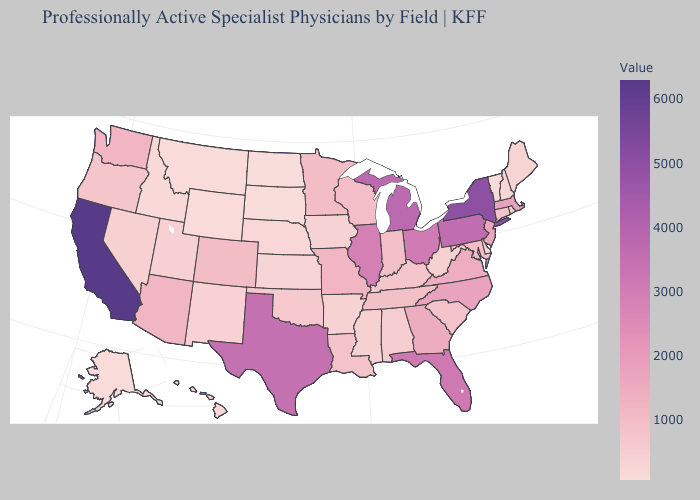Does Minnesota have the highest value in the MidWest?
Keep it brief. No. Does California have the highest value in the West?
Answer briefly. Yes. Does New York have the highest value in the Northeast?
Concise answer only. Yes. Does North Carolina have a lower value than Rhode Island?
Give a very brief answer. No. Among the states that border Arizona , does Colorado have the highest value?
Write a very short answer. No. 